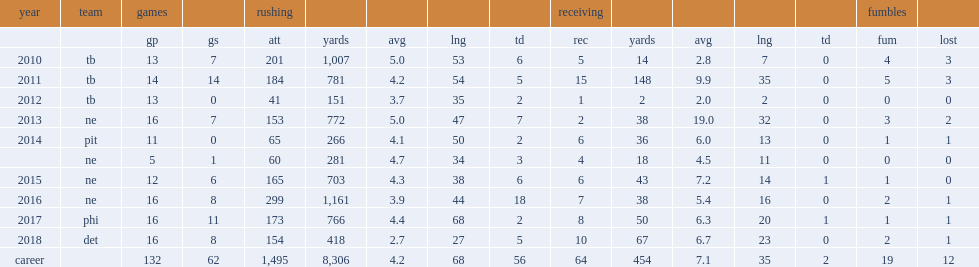Would you be able to parse every entry in this table? {'header': ['year', 'team', 'games', '', 'rushing', '', '', '', '', 'receiving', '', '', '', '', 'fumbles', ''], 'rows': [['', '', 'gp', 'gs', 'att', 'yards', 'avg', 'lng', 'td', 'rec', 'yards', 'avg', 'lng', 'td', 'fum', 'lost'], ['2010', 'tb', '13', '7', '201', '1,007', '5.0', '53', '6', '5', '14', '2.8', '7', '0', '4', '3'], ['2011', 'tb', '14', '14', '184', '781', '4.2', '54', '5', '15', '148', '9.9', '35', '0', '5', '3'], ['2012', 'tb', '13', '0', '41', '151', '3.7', '35', '2', '1', '2', '2.0', '2', '0', '0', '0'], ['2013', 'ne', '16', '7', '153', '772', '5.0', '47', '7', '2', '38', '19.0', '32', '0', '3', '2'], ['2014', 'pit', '11', '0', '65', '266', '4.1', '50', '2', '6', '36', '6.0', '13', '0', '1', '1'], ['', 'ne', '5', '1', '60', '281', '4.7', '34', '3', '4', '18', '4.5', '11', '0', '0', '0'], ['2015', 'ne', '12', '6', '165', '703', '4.3', '38', '6', '6', '43', '7.2', '14', '1', '1', '0'], ['2016', 'ne', '16', '8', '299', '1,161', '3.9', '44', '18', '7', '38', '5.4', '16', '0', '2', '1'], ['2017', 'phi', '16', '11', '173', '766', '4.4', '68', '2', '8', '50', '6.3', '20', '1', '1', '1'], ['2018', 'det', '16', '8', '154', '418', '2.7', '27', '5', '10', '67', '6.7', '23', '0', '2', '1'], ['career', '', '132', '62', '1,495', '8,306', '4.2', '68', '56', '64', '454', '7.1', '35', '2', '19', '12']]} How many rushing yards did blount make in the 2016 season? 1161.0. 